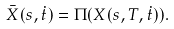Convert formula to latex. <formula><loc_0><loc_0><loc_500><loc_500>\bar { X } ( s , \dot { t } ) = \Pi ( X ( s , T , \dot { t } ) ) .</formula> 